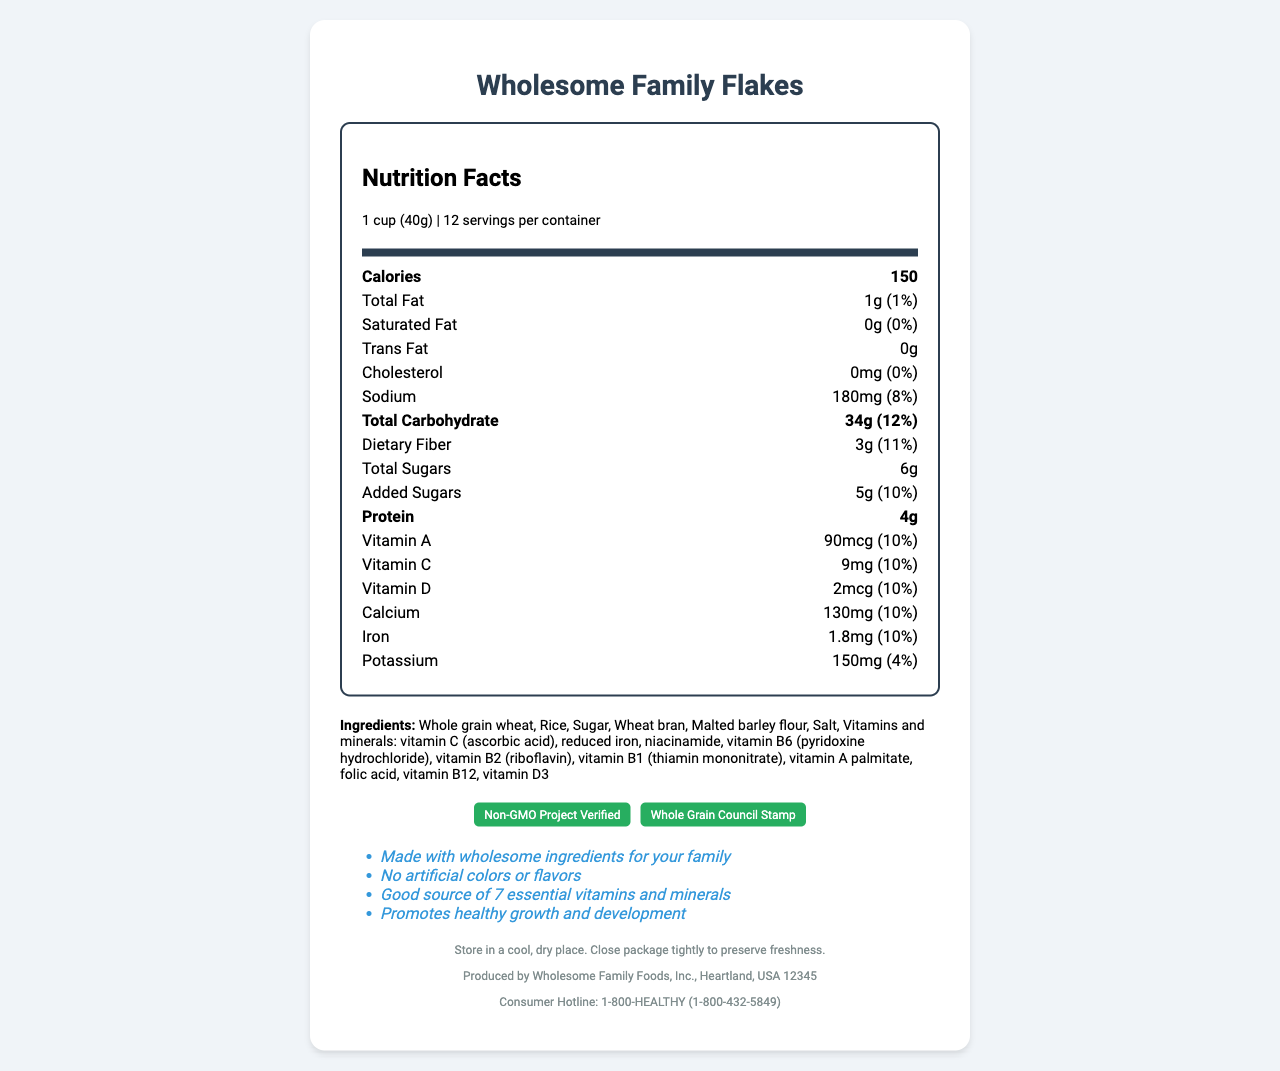what is the serving size for this cereal? The serving size is mentioned at the beginning of the nutrition label as "1 cup (40g)".
Answer: 1 cup (40g) how many servings are there per container? The servings per container are listed right under the serving size information.
Answer: 12 what is the calorie content per serving? The calories per serving are listed prominently in the nutrition facts.
Answer: 150 calories how much dietary fiber is in one serving? The dietary fiber content is listed as 3g per serving.
Answer: 3g what are the total sugars content per serving, including added sugars? The total sugars content per serving, including added sugars, is listed as 6g.
Answer: 6g which of the following vitamins is present in the highest amount? A. Vitamin A B. Vitamin C C. Vitamin D D. Iron Vitamin C is listed at 9mg per serving, which is the highest amount among the mentioned vitamins and minerals.
Answer: B. Vitamin C which certification does this product have? A. USDA Organic B. Gluten-Free Certification C. Whole Grain Council Stamp D. Fair Trade Certified The document lists "Whole Grain Council Stamp" as one of the certifications this cereal has.
Answer: C. Whole Grain Council Stamp does this cereal contain any artificial colors or flavors? The document states "No artificial colors or flavors" under the marketing claims section.
Answer: No is this product suitable for someone with a nut allergy? The allergen info indicates that the product is made in a facility that also processes tree nuts, peanuts, and soy.
Answer: No summarize the key points mentioned in this nutrition facts label. The document includes detailed information about serving size, nutritional breakdown, ingredients, and certifications, emphasized by various sections of the label.
Answer: This cereal, Wholesome Family Flakes, offers 150 calories per 1 cup serving. It has 1g total fat, 3g dietary fiber, 6g total sugars (5g added), and 4g protein per serving. The product also contains several vitamins and minerals, contributing about 10% of the daily value for many of them. Ingredients include whole grain wheat, rice, sugar, and a variety of added vitamins and minerals. The product is certified Non-GMO and has the Whole Grain Council Stamp. It is made in a facility that also processes tree nuts, peanuts, and soy. how much protein does this cereal provide per serving? The protein content is listed as 4g per serving in the nutrition facts.
Answer: 4g what is the amount of sodium in one serving? The sodium content is listed as 180mg per serving.
Answer: 180mg is this cereal low in saturated fat? The document lists 0g of saturated fat per serving, indicating that the cereal is low in saturated fat.
Answer: Yes can you determine the exact manufacturing date from this document? The document does not provide any information about the manufacturing date.
Answer: Cannot be determined which vitamins and minerals are listed as part of the ingredients? The ingredients section of the document lists several vitamins and minerals explicitly.
Answer: Vitamin C, reduced iron, niacinamide, vitamin B6, vitamin B2, vitamin B1, vitamin A palmitate, folic acid, vitamin B12, vitamin D3 